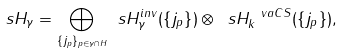<formula> <loc_0><loc_0><loc_500><loc_500>\ s H _ { \gamma } = \underset { \{ j _ { p } \} _ { p \in \gamma \cap H } } { \bigoplus } \ s H _ { \gamma } ^ { i n v } ( { \{ j _ { p } \} } ) \otimes \ s H ^ { \ v a C S } _ { k } ( { \{ j _ { p } \} } ) ,</formula> 